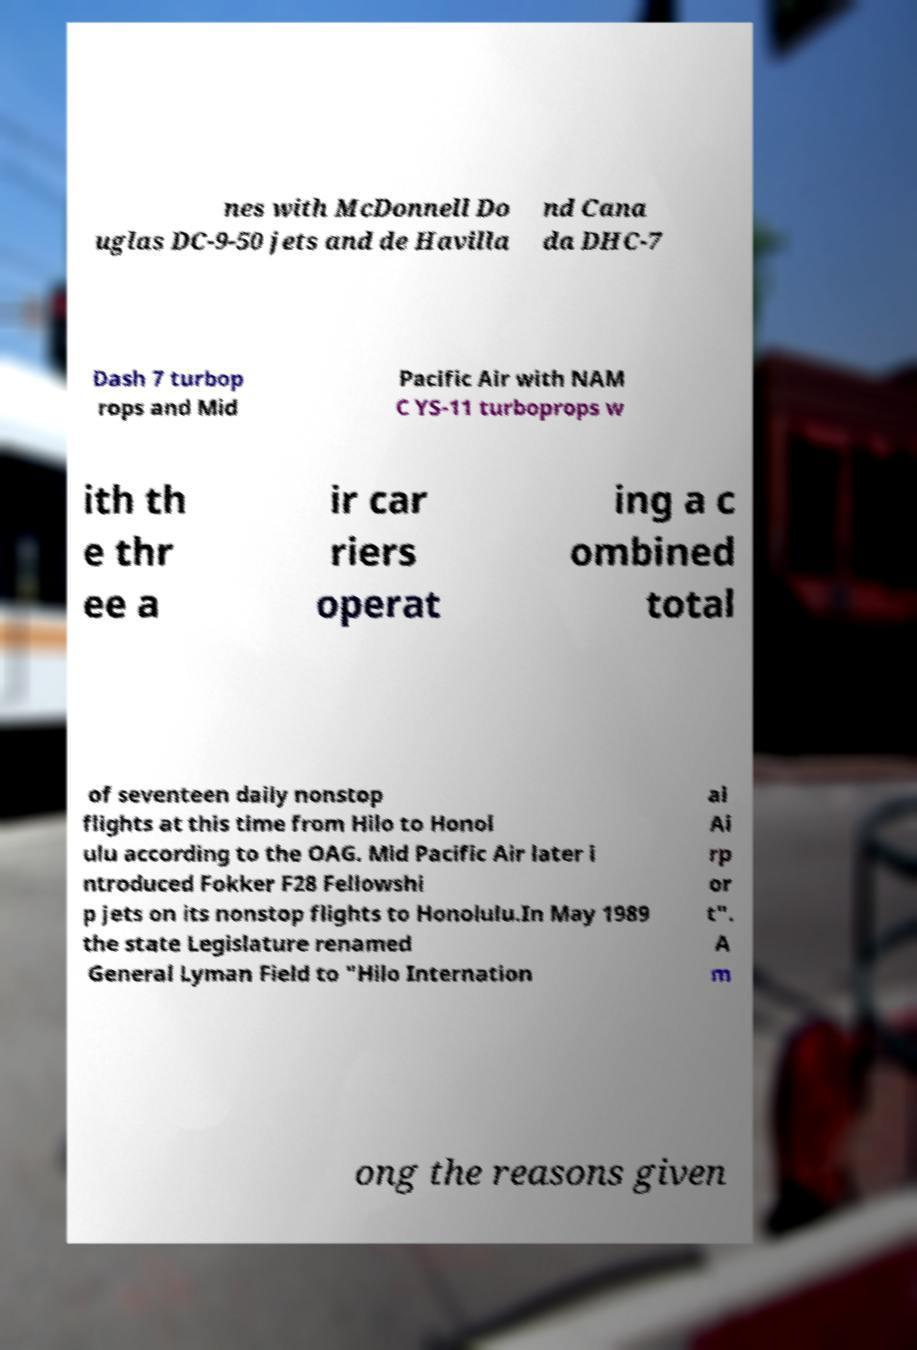Please read and relay the text visible in this image. What does it say? nes with McDonnell Do uglas DC-9-50 jets and de Havilla nd Cana da DHC-7 Dash 7 turbop rops and Mid Pacific Air with NAM C YS-11 turboprops w ith th e thr ee a ir car riers operat ing a c ombined total of seventeen daily nonstop flights at this time from Hilo to Honol ulu according to the OAG. Mid Pacific Air later i ntroduced Fokker F28 Fellowshi p jets on its nonstop flights to Honolulu.In May 1989 the state Legislature renamed General Lyman Field to "Hilo Internation al Ai rp or t". A m ong the reasons given 